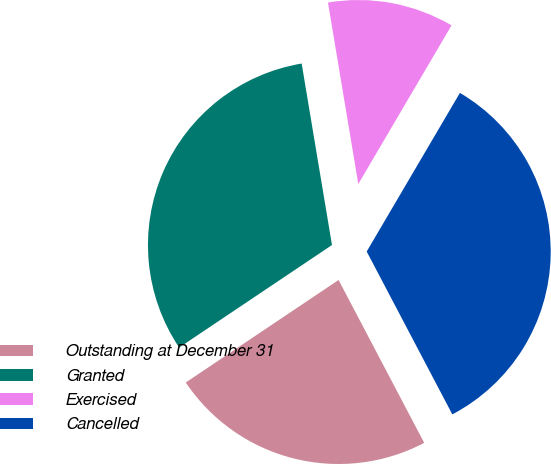Convert chart. <chart><loc_0><loc_0><loc_500><loc_500><pie_chart><fcel>Outstanding at December 31<fcel>Granted<fcel>Exercised<fcel>Cancelled<nl><fcel>23.3%<fcel>31.77%<fcel>11.09%<fcel>33.84%<nl></chart> 